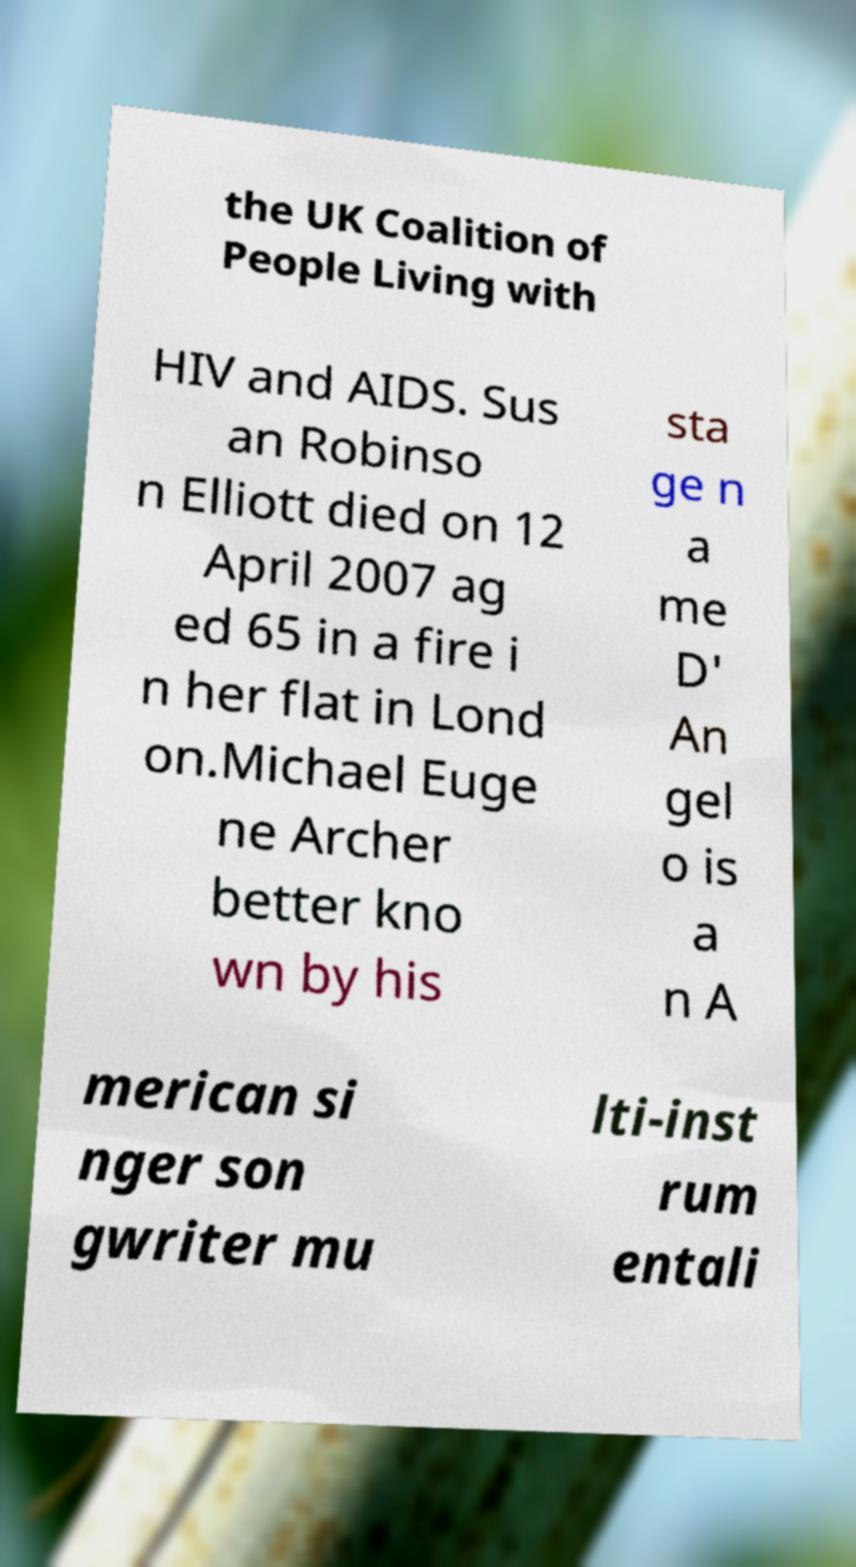Can you accurately transcribe the text from the provided image for me? the UK Coalition of People Living with HIV and AIDS. Sus an Robinso n Elliott died on 12 April 2007 ag ed 65 in a fire i n her flat in Lond on.Michael Euge ne Archer better kno wn by his sta ge n a me D' An gel o is a n A merican si nger son gwriter mu lti-inst rum entali 